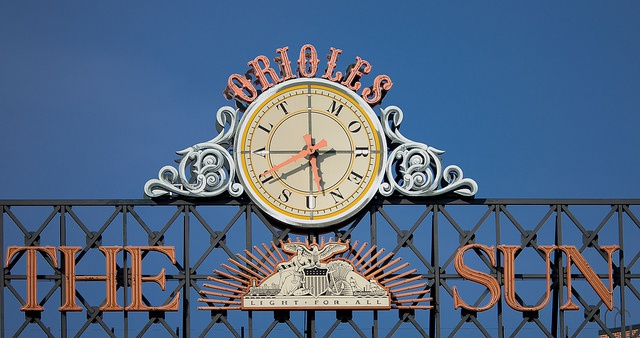Describe the objects in this image and their specific colors. I can see clock in blue, tan, lightgray, gray, and orange tones and bird in blue, darkgray, beige, and gray tones in this image. 